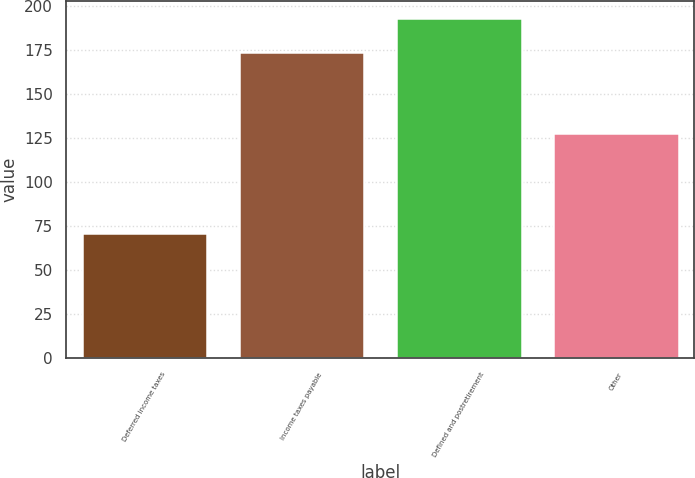Convert chart. <chart><loc_0><loc_0><loc_500><loc_500><bar_chart><fcel>Deferred income taxes<fcel>Income taxes payable<fcel>Defined and postretirement<fcel>Other<nl><fcel>71<fcel>174<fcel>193<fcel>128<nl></chart> 